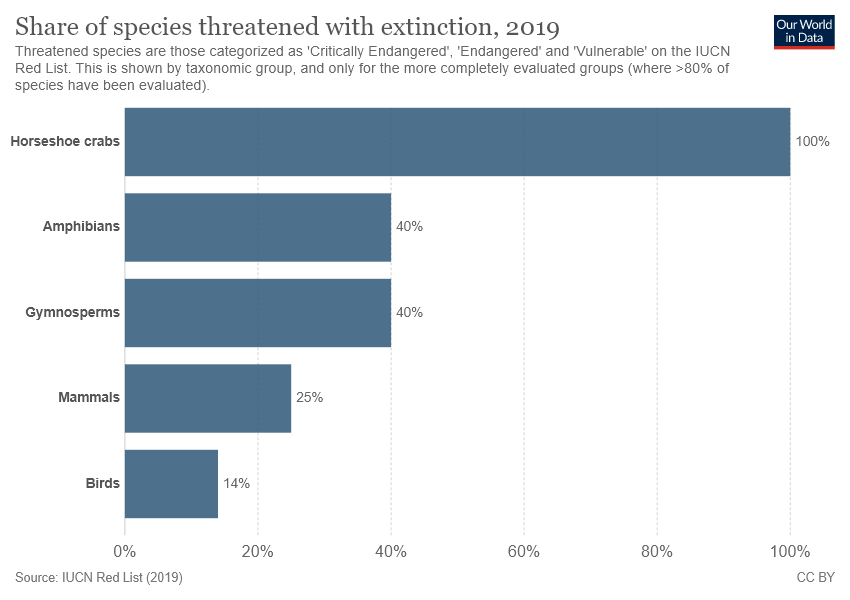Identify some key points in this picture. The value of the Amphibians and Gymnosperms is 0.4. The horseshoe crab is the species that represents the highest possible value of 100%. 